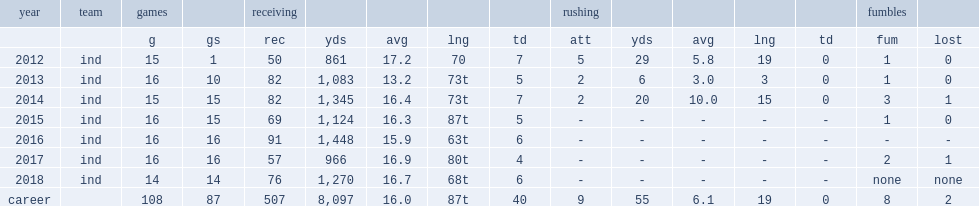How many receptions did t. y. hilton get in 2017? 57.0. 